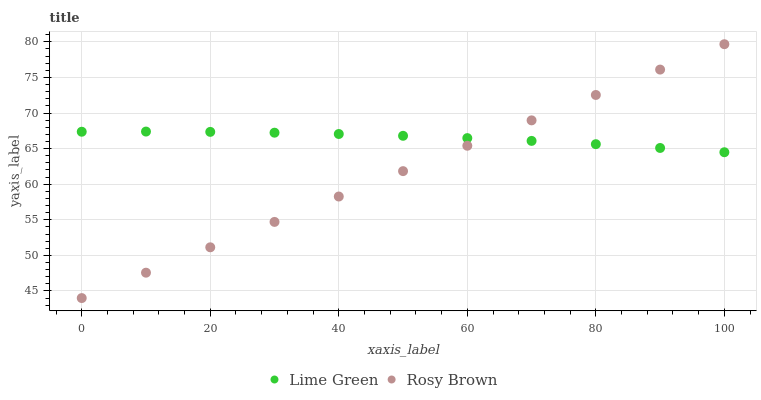Does Rosy Brown have the minimum area under the curve?
Answer yes or no. Yes. Does Lime Green have the maximum area under the curve?
Answer yes or no. Yes. Does Lime Green have the minimum area under the curve?
Answer yes or no. No. Is Rosy Brown the smoothest?
Answer yes or no. Yes. Is Lime Green the roughest?
Answer yes or no. Yes. Is Lime Green the smoothest?
Answer yes or no. No. Does Rosy Brown have the lowest value?
Answer yes or no. Yes. Does Lime Green have the lowest value?
Answer yes or no. No. Does Rosy Brown have the highest value?
Answer yes or no. Yes. Does Lime Green have the highest value?
Answer yes or no. No. Does Rosy Brown intersect Lime Green?
Answer yes or no. Yes. Is Rosy Brown less than Lime Green?
Answer yes or no. No. Is Rosy Brown greater than Lime Green?
Answer yes or no. No. 